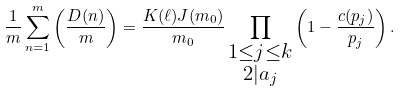Convert formula to latex. <formula><loc_0><loc_0><loc_500><loc_500>\frac { 1 } { m } \sum _ { n = 1 } ^ { m } \left ( \frac { D ( n ) } { m } \right ) = \frac { K ( \ell ) J ( m _ { 0 } ) } { m _ { 0 } } \prod _ { \substack { 1 \leq j \leq k \\ 2 | a _ { j } } } \left ( 1 - \frac { c ( p _ { j } ) } { p _ { j } } \right ) .</formula> 